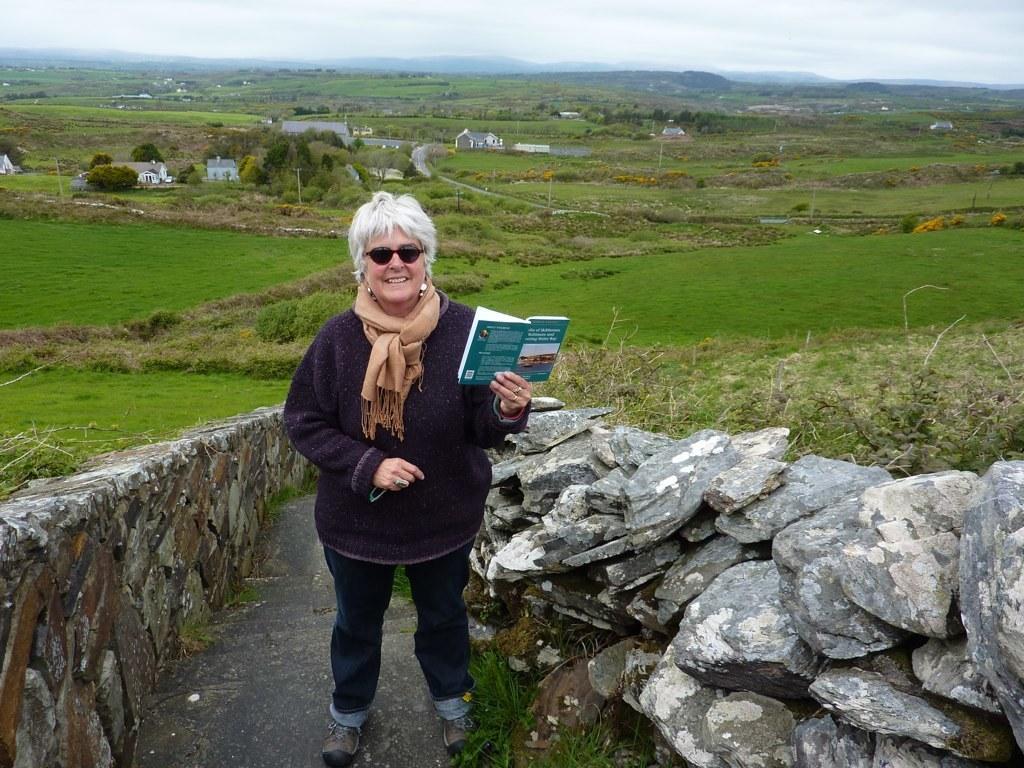How would you summarize this image in a sentence or two? In the foreground I can see a woman is standing on the staircase and holding a book in hand and stones. In the background I can grass, trees, houses, poles and water. On the top I can see mountains and the sky. This image is taken near the farm during a day. 